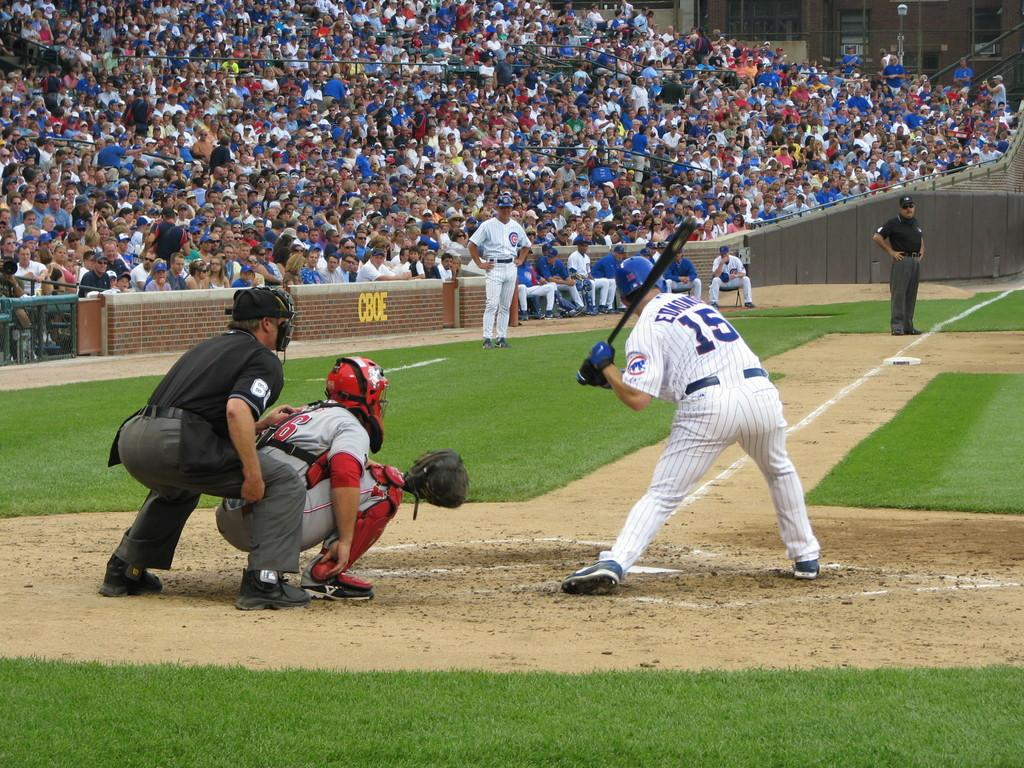What is the main activity of the people in the image? There is a group of people standing in the image, with two persons in a squat position. How are the people arranged in the image? There are groups of people standing and sitting in the image. Can you describe the positions of the people in the image? Two persons are in a squat position, while others are standing. There are also groups of people sitting behind the standing people. What type of veil is being used by the people in the image? There is no veil present in the image; the people are not wearing any type of veil. How much profit can be seen being made by the people in the image? There is no indication of profit or any financial activity in the image. 